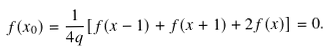Convert formula to latex. <formula><loc_0><loc_0><loc_500><loc_500>f ( x _ { 0 } ) = \frac { 1 } { 4 q } [ f ( x - 1 ) + f ( x + 1 ) + 2 f ( x ) ] = 0 .</formula> 